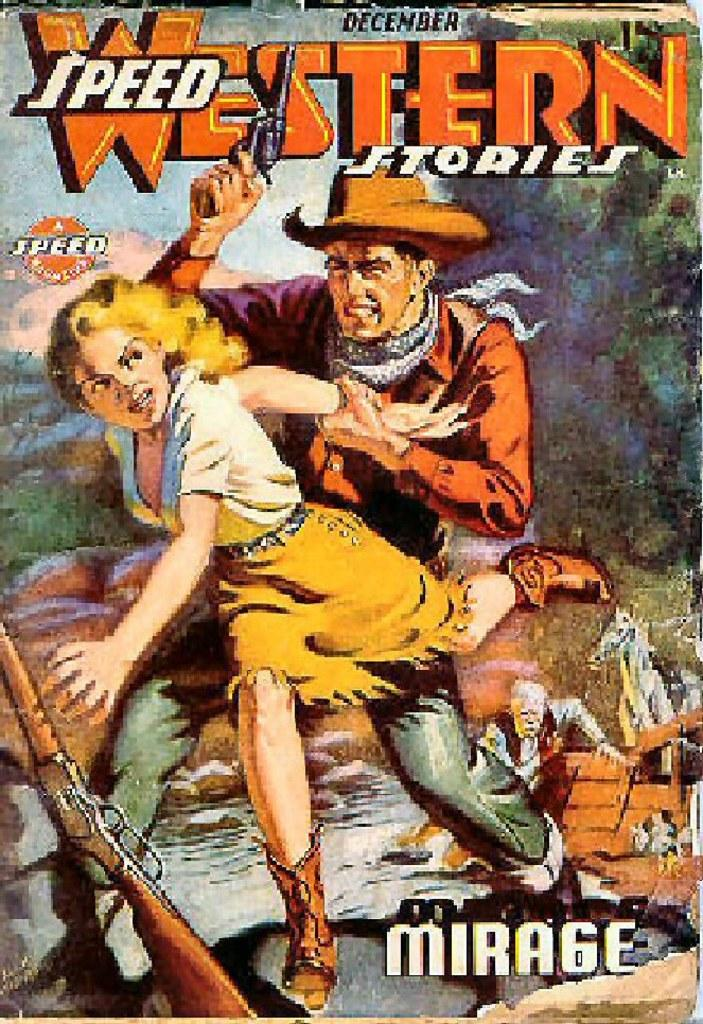<image>
Summarize the visual content of the image. An old magazine called Speed Western Stories, Mirage 